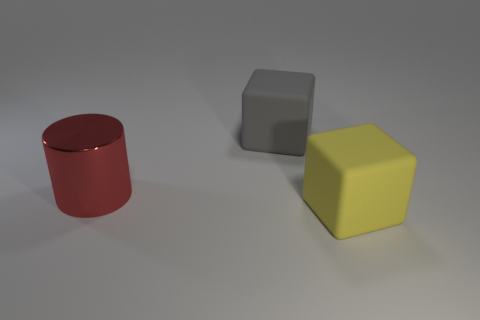Add 2 large yellow rubber cubes. How many objects exist? 5 Subtract all cubes. How many objects are left? 1 Add 3 yellow blocks. How many yellow blocks exist? 4 Subtract 0 red cubes. How many objects are left? 3 Subtract all blocks. Subtract all brown rubber cylinders. How many objects are left? 1 Add 1 cylinders. How many cylinders are left? 2 